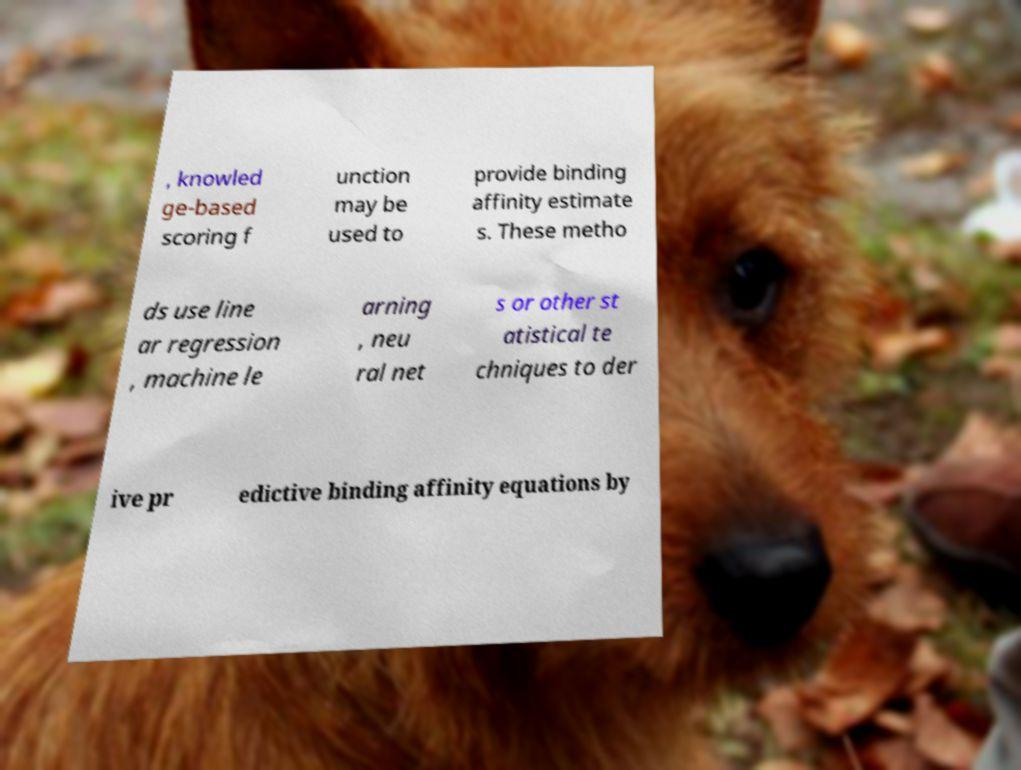What messages or text are displayed in this image? I need them in a readable, typed format. , knowled ge-based scoring f unction may be used to provide binding affinity estimate s. These metho ds use line ar regression , machine le arning , neu ral net s or other st atistical te chniques to der ive pr edictive binding affinity equations by 